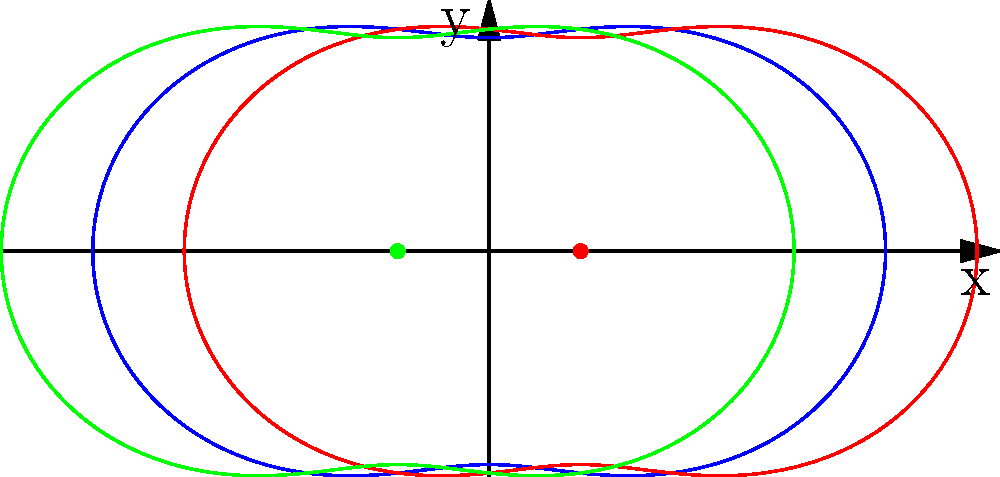Consider an electric dipole consisting of two equal and opposite charges located at $(0.3,0)$ and $(-0.3,0)$ in polar coordinates. The equipotential lines of this dipole can be approximated by the equation $r = a + b \cos(2\theta)$, where $a$ and $b$ are constants. Based on the graph shown, what is the approximate value of $\frac{b}{a}$ for the blue curve? To find the ratio $\frac{b}{a}$, we need to analyze the given equation and the graph:

1) The equation $r = a + b \cos(2\theta)$ represents the equipotential lines in polar form.

2) $a$ represents the average radius of the curve, while $b$ represents the amplitude of the variation.

3) From the graph, we can see that the blue curve oscillates around $r = 1$.

4) The maximum radius occurs at $\theta = 0$ and $\pi$, while the minimum radius occurs at $\theta = \frac{\pi}{2}$ and $\frac{3\pi}{2}$.

5) At the maximum: $r_{max} = a + b$
   At the minimum: $r_{min} = a - b$

6) From the graph, we can estimate $r_{max} \approx 1.3$ and $r_{min} \approx 0.7$

7) Therefore: $a + b \approx 1.3$ and $a - b \approx 0.7$

8) Adding these equations: $2a \approx 2$, so $a \approx 1$

9) Subtracting the equations: $2b \approx 0.6$, so $b \approx 0.3$

10) The ratio $\frac{b}{a} \approx \frac{0.3}{1} = 0.3$
Answer: $0.3$ 